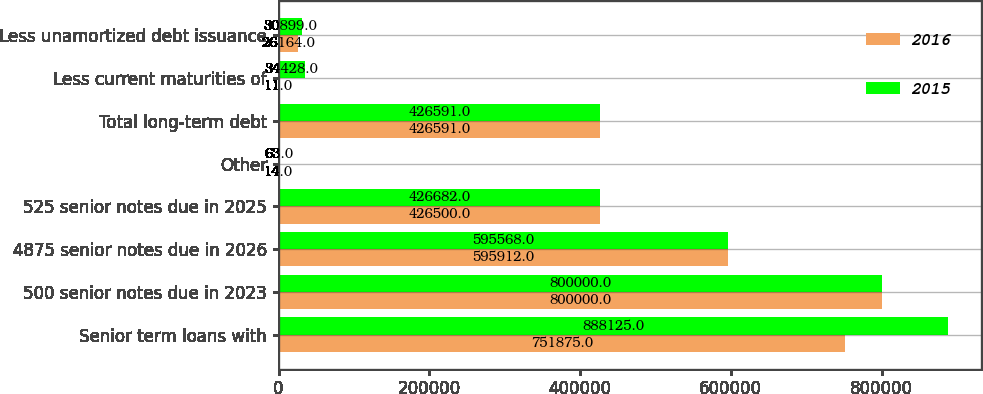Convert chart. <chart><loc_0><loc_0><loc_500><loc_500><stacked_bar_chart><ecel><fcel>Senior term loans with<fcel>500 senior notes due in 2023<fcel>4875 senior notes due in 2026<fcel>525 senior notes due in 2025<fcel>Other<fcel>Total long-term debt<fcel>Less current maturities of<fcel>Less unamortized debt issuance<nl><fcel>2016<fcel>751875<fcel>800000<fcel>595912<fcel>426500<fcel>14<fcel>426591<fcel>11<fcel>26164<nl><fcel>2015<fcel>888125<fcel>800000<fcel>595568<fcel>426682<fcel>63<fcel>426591<fcel>34428<fcel>30899<nl></chart> 